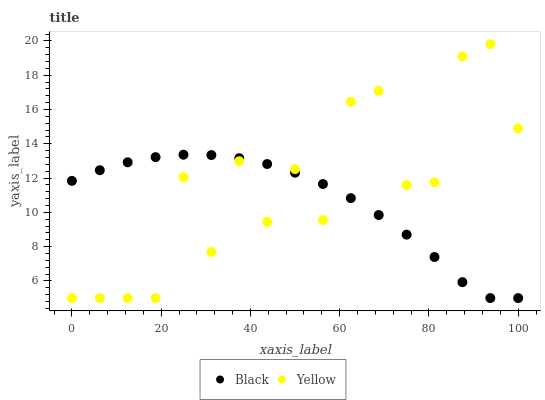Does Black have the minimum area under the curve?
Answer yes or no. Yes. Does Yellow have the maximum area under the curve?
Answer yes or no. Yes. Does Yellow have the minimum area under the curve?
Answer yes or no. No. Is Black the smoothest?
Answer yes or no. Yes. Is Yellow the roughest?
Answer yes or no. Yes. Is Yellow the smoothest?
Answer yes or no. No. Does Black have the lowest value?
Answer yes or no. Yes. Does Yellow have the highest value?
Answer yes or no. Yes. Does Yellow intersect Black?
Answer yes or no. Yes. Is Yellow less than Black?
Answer yes or no. No. Is Yellow greater than Black?
Answer yes or no. No. 